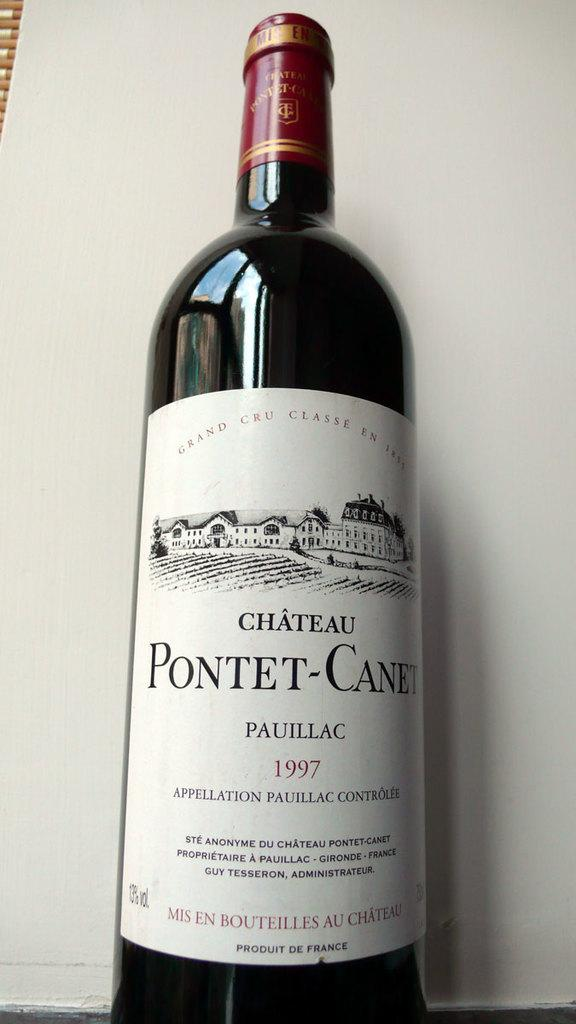What object is present in the image that can hold a liquid? There is a bottle in the image that can hold a liquid. What is on the bottle that provides additional information or decoration? The bottle has a sticker on it. What is depicted on the sticker? The sticker has text and a figure. How can the bottle be sealed to prevent spills? The bottle has a lid. What can be seen behind the bottle in the image? There is a white wall in the background of the image. What type of hate or attraction can be seen between the bottle and the wall in the image? There is no hate or attraction depicted between the bottle and the wall in the image; they are separate objects in the scene. 